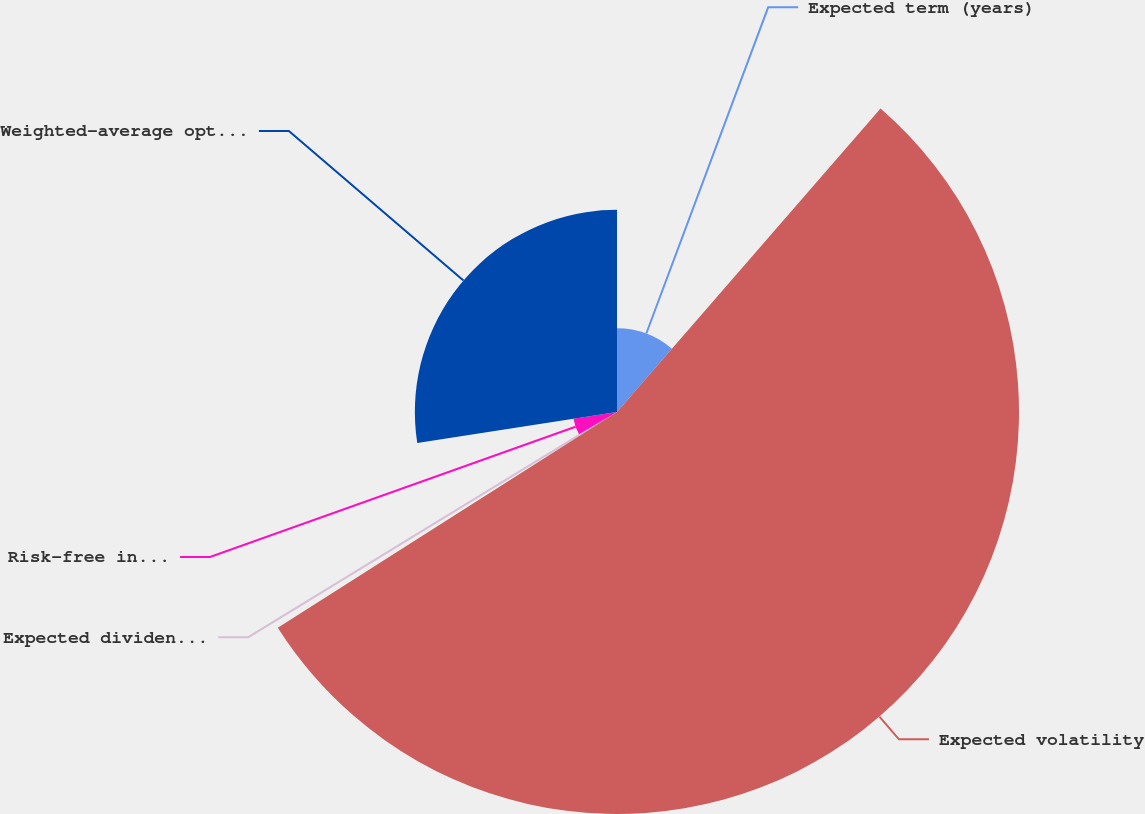Convert chart to OTSL. <chart><loc_0><loc_0><loc_500><loc_500><pie_chart><fcel>Expected term (years)<fcel>Expected volatility<fcel>Expected dividend yield<fcel>Risk-free interest rate<fcel>Weighted-average option grant<nl><fcel>11.38%<fcel>54.61%<fcel>0.58%<fcel>5.98%<fcel>27.46%<nl></chart> 